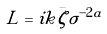<formula> <loc_0><loc_0><loc_500><loc_500>L = i k \bar { \zeta } \sigma ^ { - 2 a }</formula> 